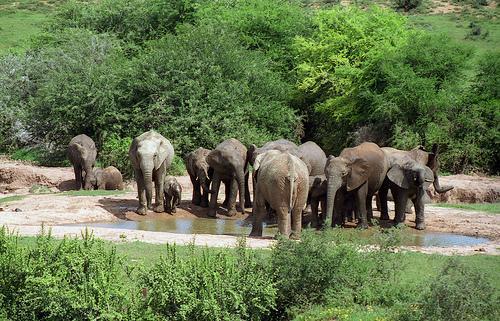How many elephants are facing toward the camera?
Give a very brief answer. 6. 